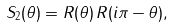Convert formula to latex. <formula><loc_0><loc_0><loc_500><loc_500>S _ { 2 } ( \theta ) = R ( \theta ) \, R ( i \pi - \theta ) ,</formula> 